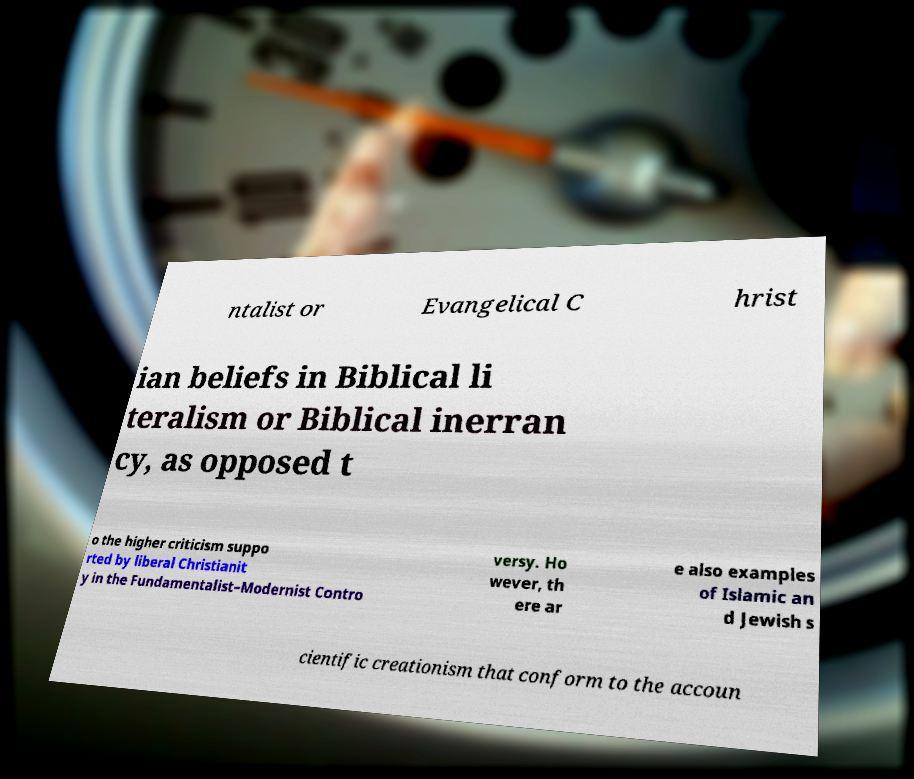There's text embedded in this image that I need extracted. Can you transcribe it verbatim? ntalist or Evangelical C hrist ian beliefs in Biblical li teralism or Biblical inerran cy, as opposed t o the higher criticism suppo rted by liberal Christianit y in the Fundamentalist–Modernist Contro versy. Ho wever, th ere ar e also examples of Islamic an d Jewish s cientific creationism that conform to the accoun 